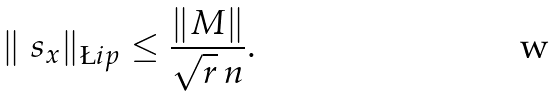<formula> <loc_0><loc_0><loc_500><loc_500>\| \ s _ { x } \| _ { \L i p } \leq \frac { \| M \| } { \sqrt { r } \, n } .</formula> 